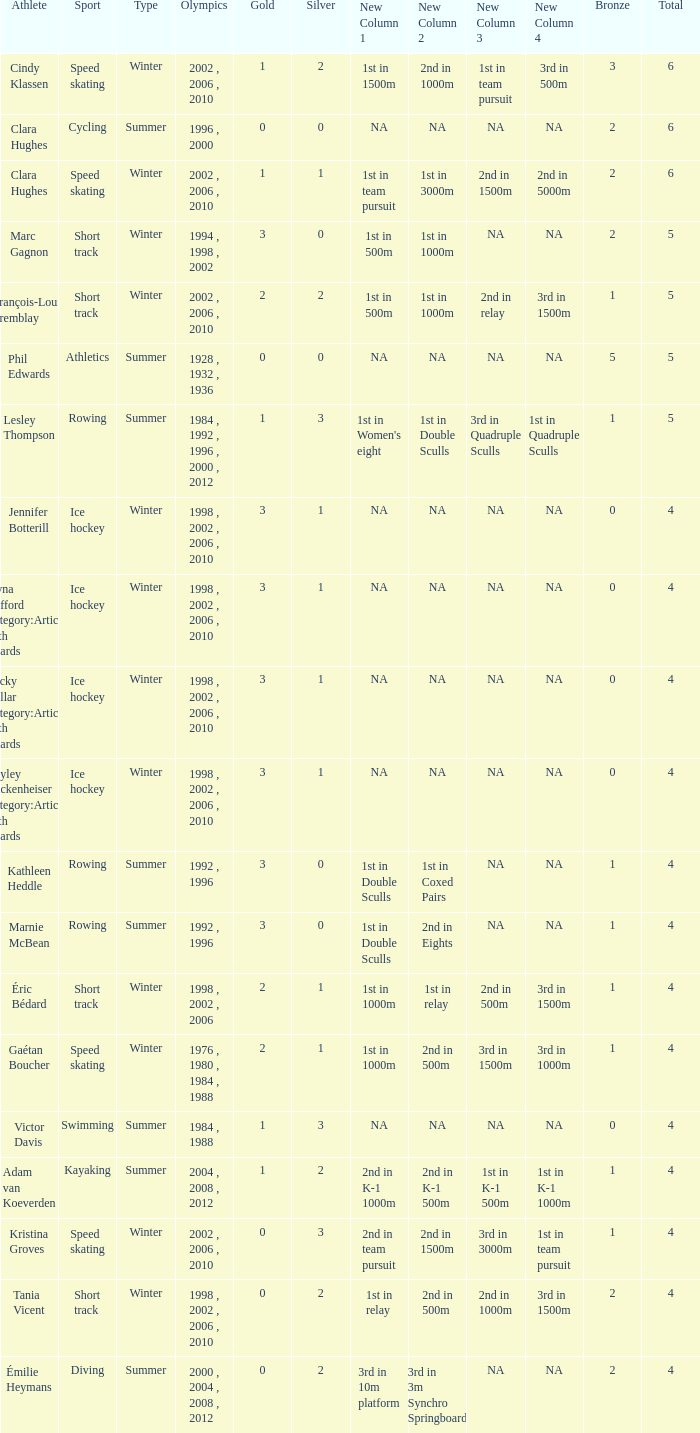What is the highest total medals winter athlete Clara Hughes has? 6.0. 